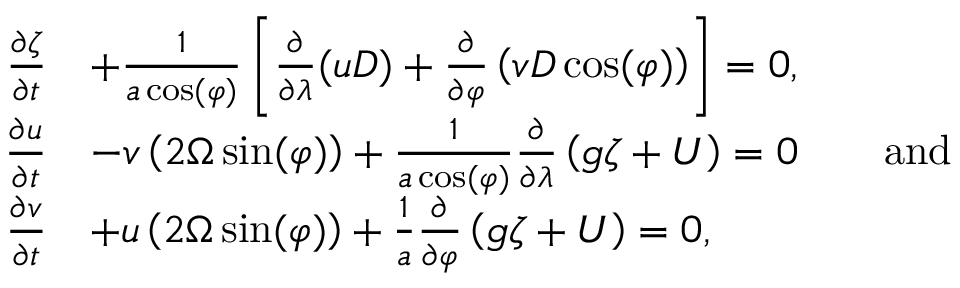<formula> <loc_0><loc_0><loc_500><loc_500>{ \begin{array} { r l } { { \frac { \partial \zeta } { \partial t } } } & { + { \frac { 1 } { a \cos ( \varphi ) } } \left [ { \frac { \partial } { \partial \lambda } } ( u D ) + { \frac { \partial } { \partial \varphi } } \left ( v D \cos ( \varphi ) \right ) \right ] = 0 , } \\ { { \frac { \partial u } { \partial t } } } & { - v \left ( 2 \Omega \sin ( \varphi ) \right ) + { \frac { 1 } { a \cos ( \varphi ) } } { \frac { \partial } { \partial \lambda } } \left ( g \zeta + U \right ) = 0 \quad { a n d } } \\ { { \frac { \partial v } { \partial t } } } & { + u \left ( 2 \Omega \sin ( \varphi ) \right ) + { \frac { 1 } { a } } { \frac { \partial } { \partial \varphi } } \left ( g \zeta + U \right ) = 0 , } \end{array} }</formula> 